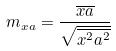<formula> <loc_0><loc_0><loc_500><loc_500>m _ { x a } = \frac { \overline { x a } } { \sqrt { \overline { x ^ { 2 } } \overline { a ^ { 2 } } } }</formula> 